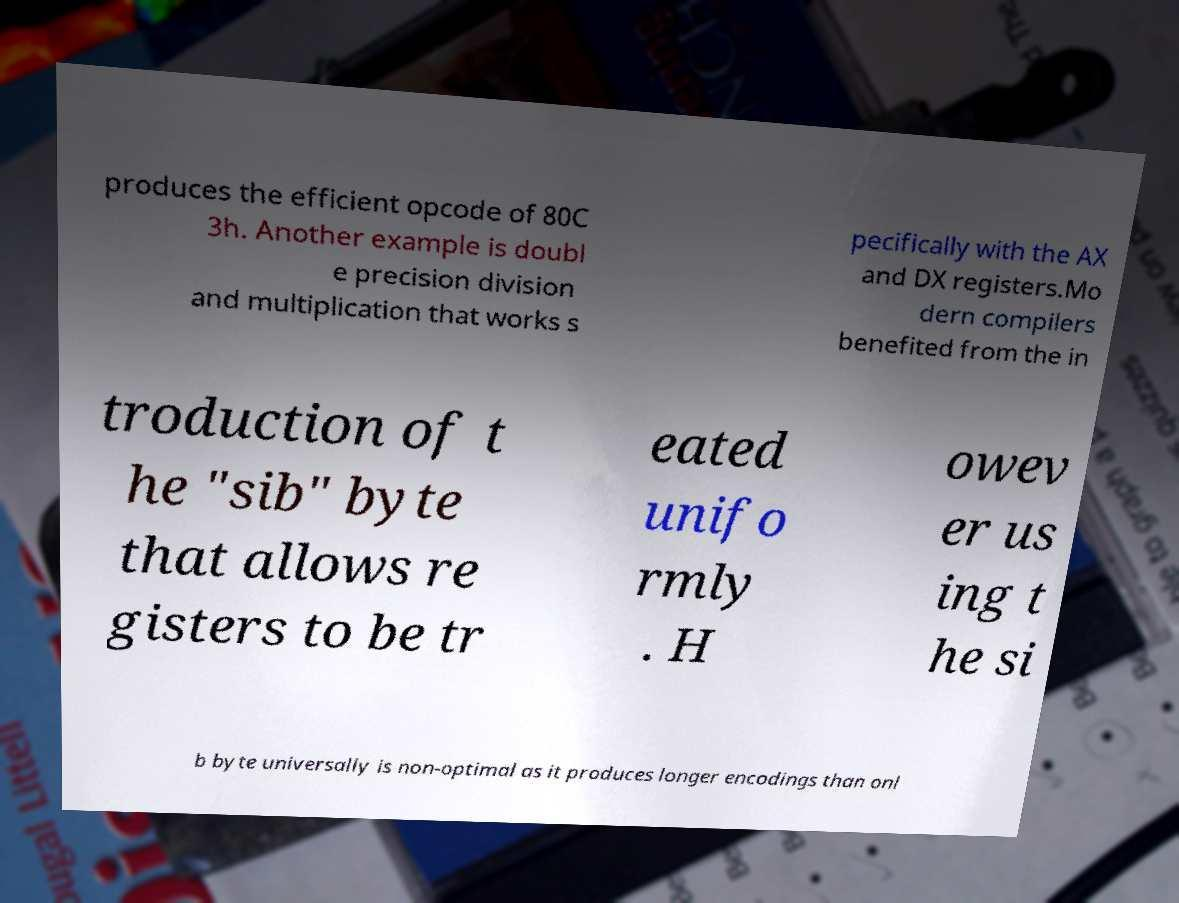There's text embedded in this image that I need extracted. Can you transcribe it verbatim? produces the efficient opcode of 80C 3h. Another example is doubl e precision division and multiplication that works s pecifically with the AX and DX registers.Mo dern compilers benefited from the in troduction of t he "sib" byte that allows re gisters to be tr eated unifo rmly . H owev er us ing t he si b byte universally is non-optimal as it produces longer encodings than onl 